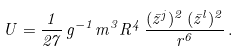Convert formula to latex. <formula><loc_0><loc_0><loc_500><loc_500>U = \frac { 1 } { 2 7 } \, g ^ { - 1 } m ^ { 3 } R ^ { 4 } \, \frac { ( { \bar { z } } ^ { j } ) ^ { 2 } \, ( { \bar { z } } ^ { l } ) ^ { 2 } } { r ^ { 6 } } \, .</formula> 